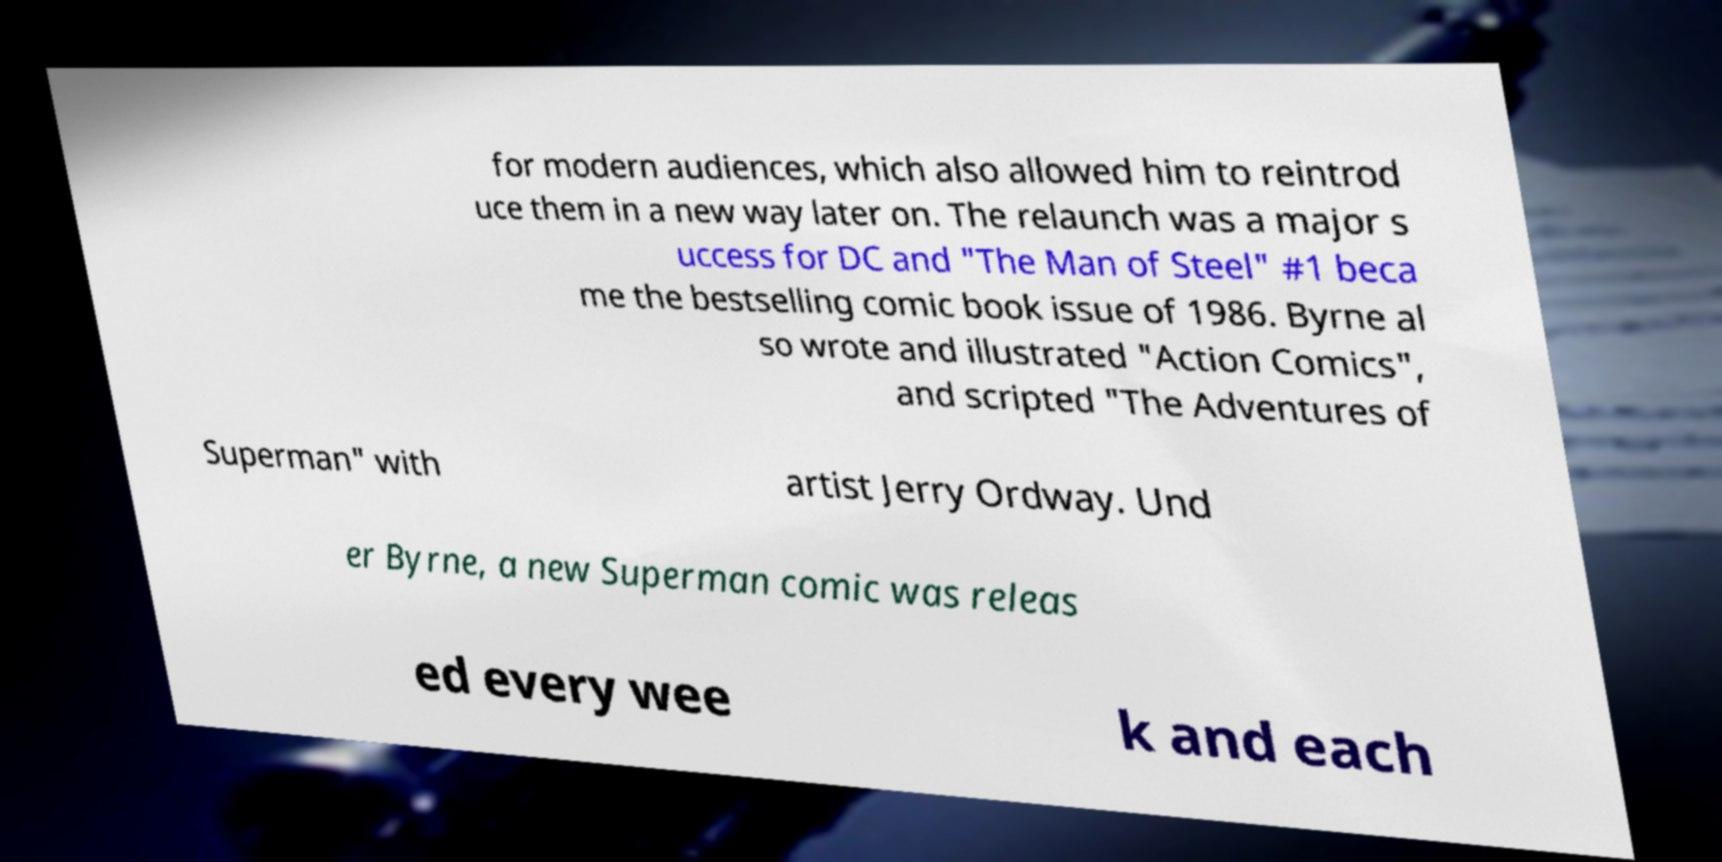Can you accurately transcribe the text from the provided image for me? for modern audiences, which also allowed him to reintrod uce them in a new way later on. The relaunch was a major s uccess for DC and "The Man of Steel" #1 beca me the bestselling comic book issue of 1986. Byrne al so wrote and illustrated "Action Comics", and scripted "The Adventures of Superman" with artist Jerry Ordway. Und er Byrne, a new Superman comic was releas ed every wee k and each 